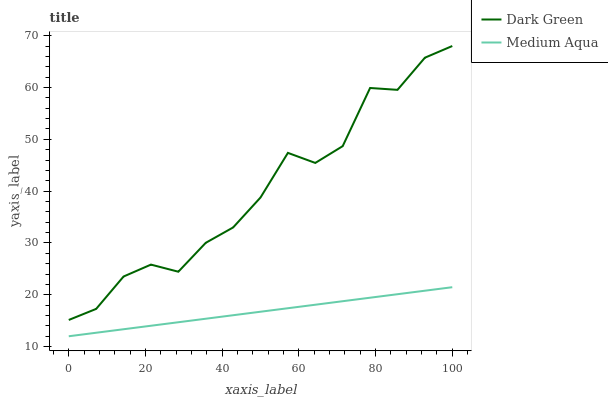Does Medium Aqua have the minimum area under the curve?
Answer yes or no. Yes. Does Dark Green have the maximum area under the curve?
Answer yes or no. Yes. Does Dark Green have the minimum area under the curve?
Answer yes or no. No. Is Medium Aqua the smoothest?
Answer yes or no. Yes. Is Dark Green the roughest?
Answer yes or no. Yes. Is Dark Green the smoothest?
Answer yes or no. No. Does Medium Aqua have the lowest value?
Answer yes or no. Yes. Does Dark Green have the lowest value?
Answer yes or no. No. Does Dark Green have the highest value?
Answer yes or no. Yes. Is Medium Aqua less than Dark Green?
Answer yes or no. Yes. Is Dark Green greater than Medium Aqua?
Answer yes or no. Yes. Does Medium Aqua intersect Dark Green?
Answer yes or no. No. 